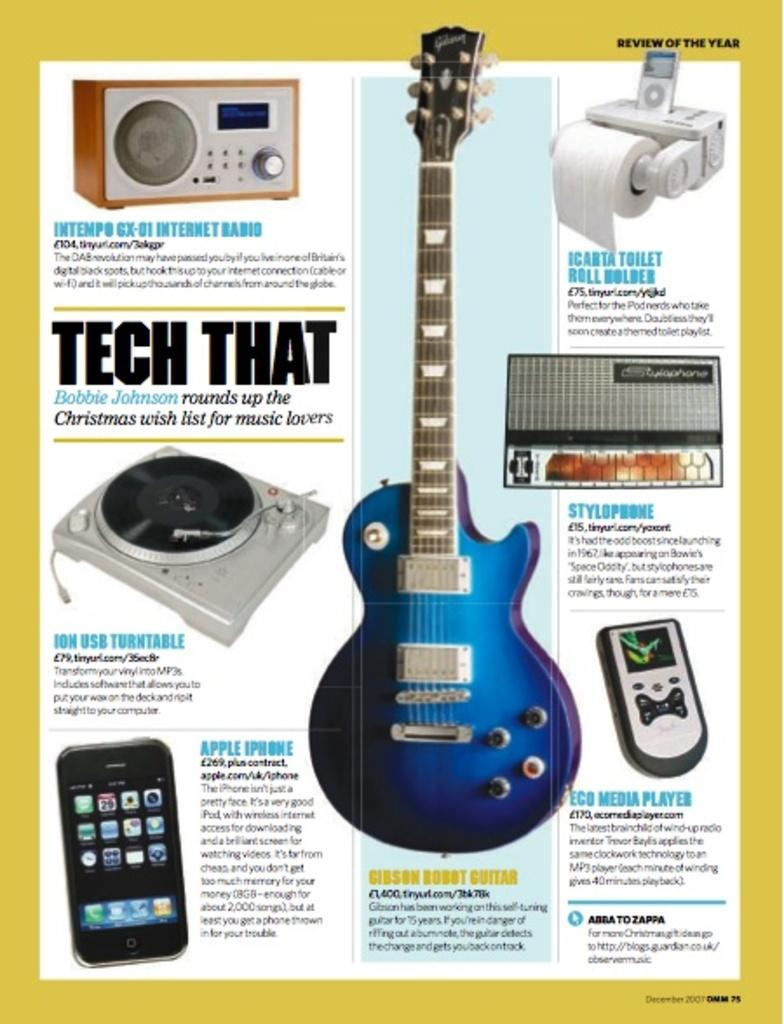Provide a one-sentence caption for the provided image. A magazine spread about Tech That features phones and guitars. 